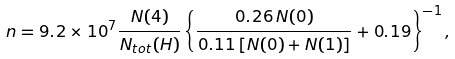Convert formula to latex. <formula><loc_0><loc_0><loc_500><loc_500>n = 9 . 2 \times 1 0 ^ { 7 } \frac { N ( 4 ) } { N _ { t o t } ( H ) } \left \{ \frac { 0 . 2 6 \, N ( 0 ) } { 0 . 1 1 \, [ N ( 0 ) + N ( 1 ) ] } + 0 . 1 9 \right \} ^ { - 1 } ,</formula> 